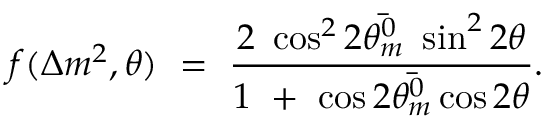Convert formula to latex. <formula><loc_0><loc_0><loc_500><loc_500>f ( \Delta m ^ { 2 } , \theta ) \ = \ \frac { 2 \ \cos ^ { 2 } 2 \bar { \theta _ { m } ^ { 0 } } \ \sin ^ { 2 } 2 \theta } { 1 \ + \ \cos 2 \bar { \theta _ { m } ^ { 0 } } \cos 2 \theta } .</formula> 